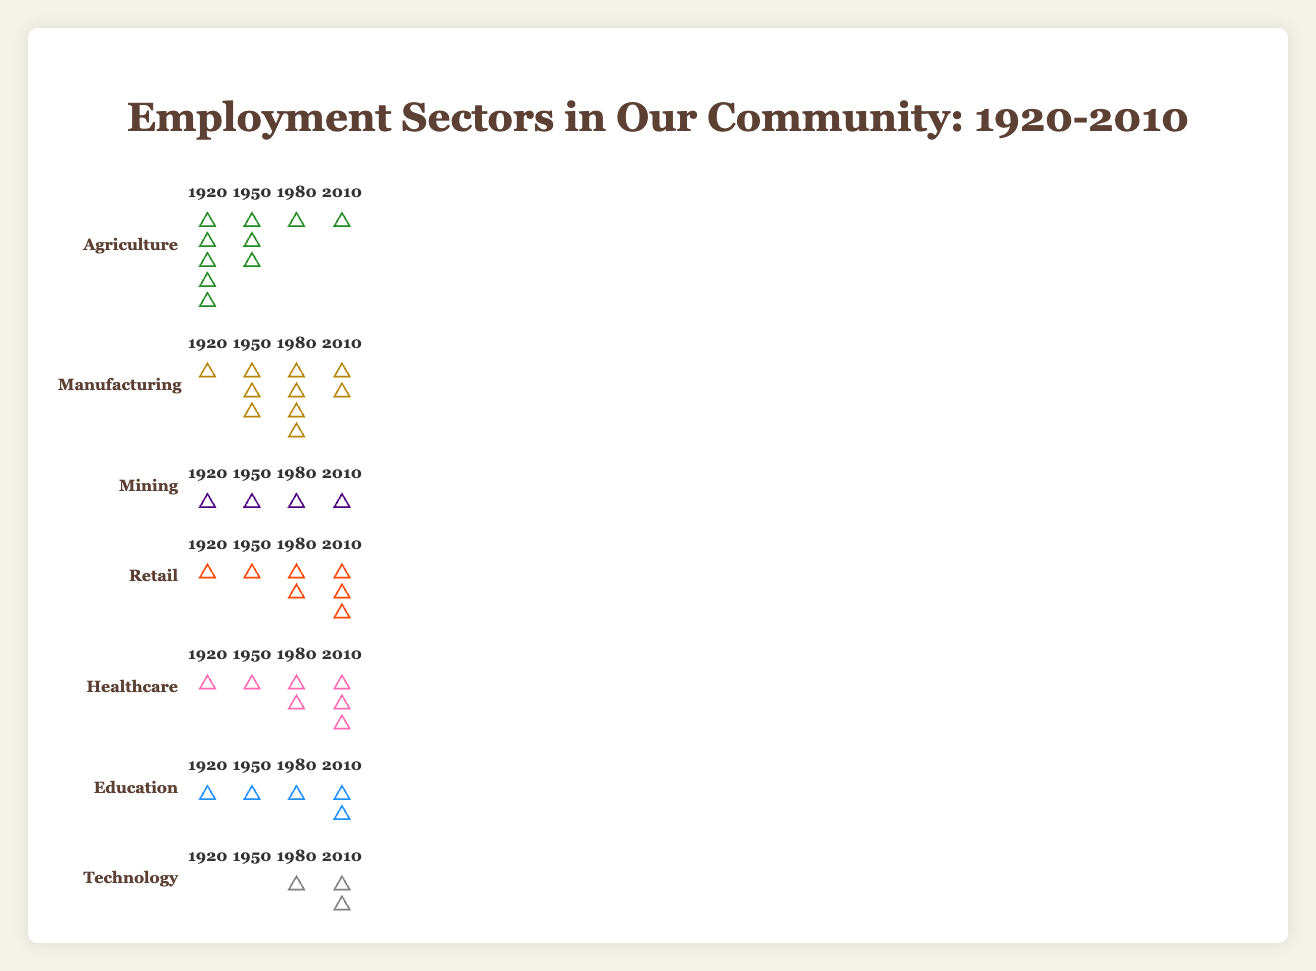How does the number of icons for Agriculture change from 1920 to 2010? The figure shows the number of icons representing Agriculture decreasing from 20 in 1920 to 2 in 2010. This is a significant reduction over the century.
Answer: Decreases significantly Which sector saw the most significant increase in icons from 1920 to 2010? By examining the number of icons across the years, Healthcare increased from 1 icon in 1920 to 15 icons in 2010, the most significant increase among all sectors.
Answer: Healthcare What is the combined number of icons for Manufacturing and Retail in 1980? The number of Manufacturing icons in 1980 is 18 and Retail icons is 8. Adding them together gives 18 + 8 = 26.
Answer: 26 Compare the number of icons for the Agriculture and Technology sectors in 2010. Which one is greater? Looking at the year 2010, Agriculture has 2 icons and Technology has 10 icons. Clearly, Technology has more icons than Agriculture.
Answer: Technology In which year did Mining have the highest number of icons, and how many were there? Mining had the highest number of icons in 1950 with 5 icons.
Answer: 1950 with 5 icons What is the total number of icons for all sectors combined in 1950? Sum up the icons in 1950 for all sectors: 12 (Agriculture) + 15 (Manufacturing) + 5 (Mining) + 5 (Retail) + 3 (Healthcare) + 2 (Education) + 0 (Technology) = 42.
Answer: 42 Which sector showed the least change in the number of icons from 1920 to 2010? Mining started with 3 icons in 1920 and reduced to 1 icon in 2010, which is a relatively small change compared to other sectors.
Answer: Mining How did the number of icons for the Education sector change from 1920 to 2010? Education had 1 icon in 1920 and 8 icons in 2010, showing a gradual increase over the years.
Answer: Increased gradually Between 1950 and 1980, did any sector experience a decrease in the number of icons? If so, which one? Between these years, the Manufacturing sector decreased from 15 to 18 icons to 15.
Answer: No Arrange the sectors in descending order based on their number of icons in 2010. In 2010, the sectors' icons are: 
1. Healthcare (15)
2. Technology (10)
3. Manufacturing (10)
4. Retail (12)
5. Education (8)
6. Agriculture (2)
7. Mining (1)
Answer: Healthcare, Retail, Technology and Manufacturing, Education, Agriculture, Mining 